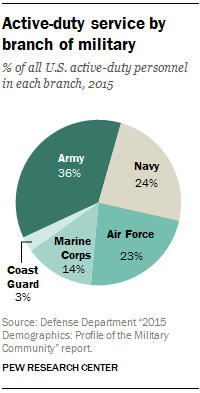Highlight a few significant elements in this photo. The total percentage of Army and Coast Guard is not greater than the total percentage of Navy and Air Force. 